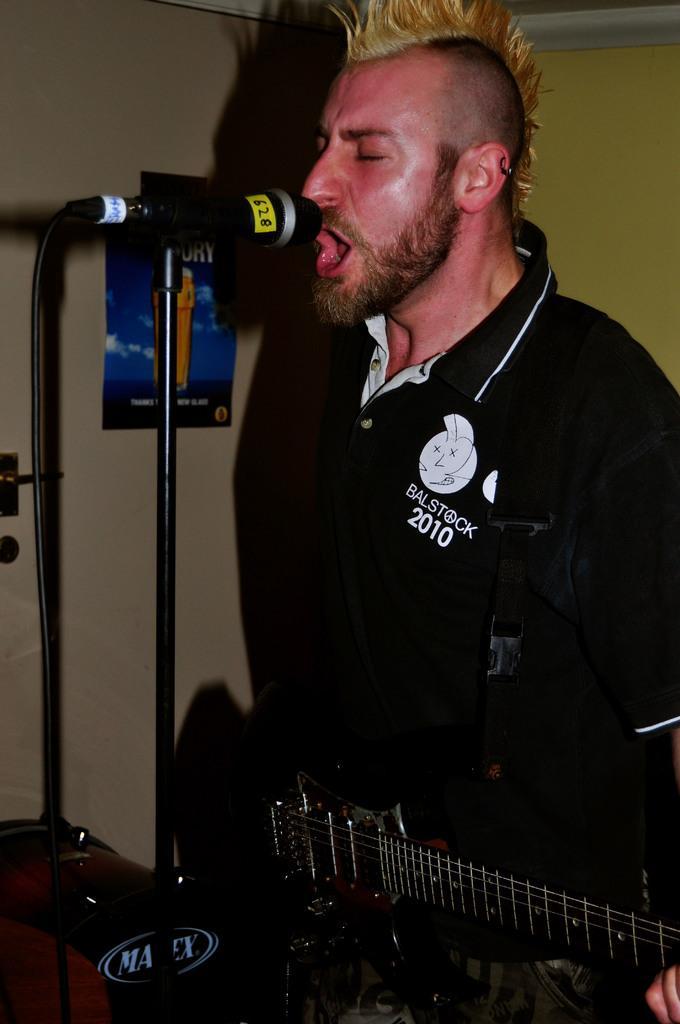How would you summarize this image in a sentence or two? This image looks likes to be clicked in a musical concert. Here this man is holding a guitar and singing something , he is on the right side of the image. He is wearing black shirt. mic is placed in front of him. There is a poster on the wall beside him 